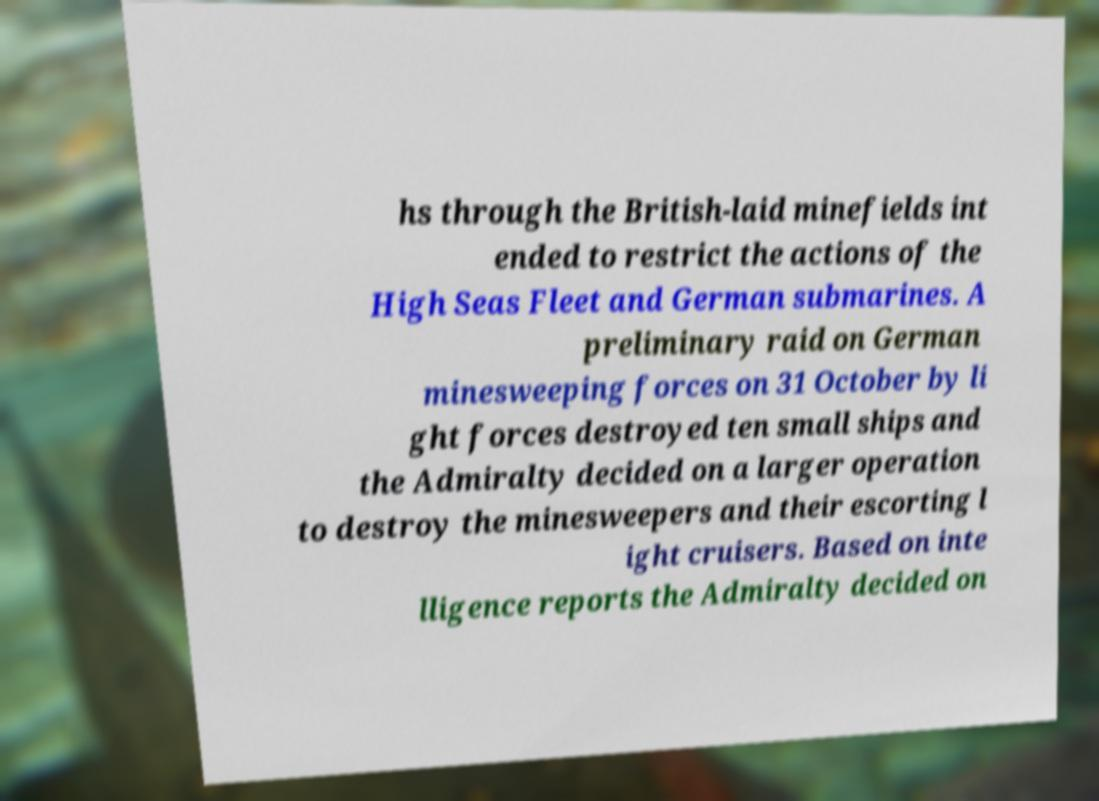What messages or text are displayed in this image? I need them in a readable, typed format. hs through the British-laid minefields int ended to restrict the actions of the High Seas Fleet and German submarines. A preliminary raid on German minesweeping forces on 31 October by li ght forces destroyed ten small ships and the Admiralty decided on a larger operation to destroy the minesweepers and their escorting l ight cruisers. Based on inte lligence reports the Admiralty decided on 